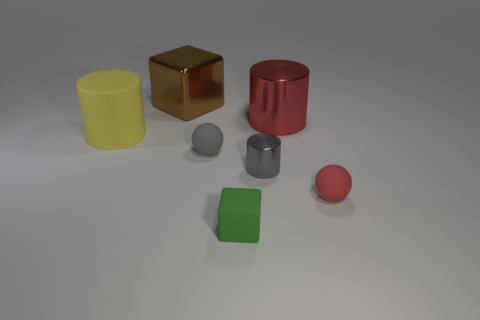There is a rubber thing that is the same color as the tiny metal object; what shape is it?
Provide a short and direct response. Sphere. Do the red shiny thing and the gray rubber thing have the same shape?
Make the answer very short. No. There is a cylinder that is both in front of the red metal cylinder and right of the tiny green matte block; what material is it made of?
Your answer should be compact. Metal. What is the size of the gray metallic object?
Offer a terse response. Small. The tiny object that is the same shape as the big red object is what color?
Your response must be concise. Gray. Is there any other thing that has the same color as the small shiny object?
Keep it short and to the point. Yes. Is the size of the object that is on the left side of the brown block the same as the red thing in front of the big red cylinder?
Your answer should be compact. No. Is the number of brown objects that are on the right side of the large brown shiny cube the same as the number of gray things behind the green object?
Offer a terse response. No. Do the matte block and the cylinder behind the large yellow rubber object have the same size?
Offer a terse response. No. There is a big shiny thing that is on the right side of the metallic block; are there any large brown cubes that are on the left side of it?
Give a very brief answer. Yes. 